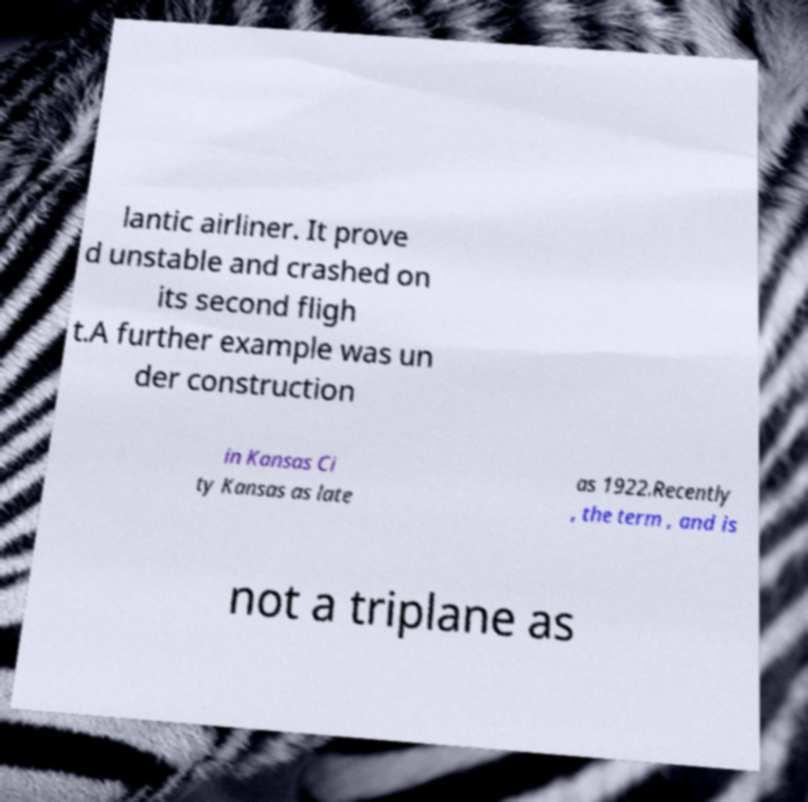Can you read and provide the text displayed in the image?This photo seems to have some interesting text. Can you extract and type it out for me? lantic airliner. It prove d unstable and crashed on its second fligh t.A further example was un der construction in Kansas Ci ty Kansas as late as 1922.Recently , the term , and is not a triplane as 